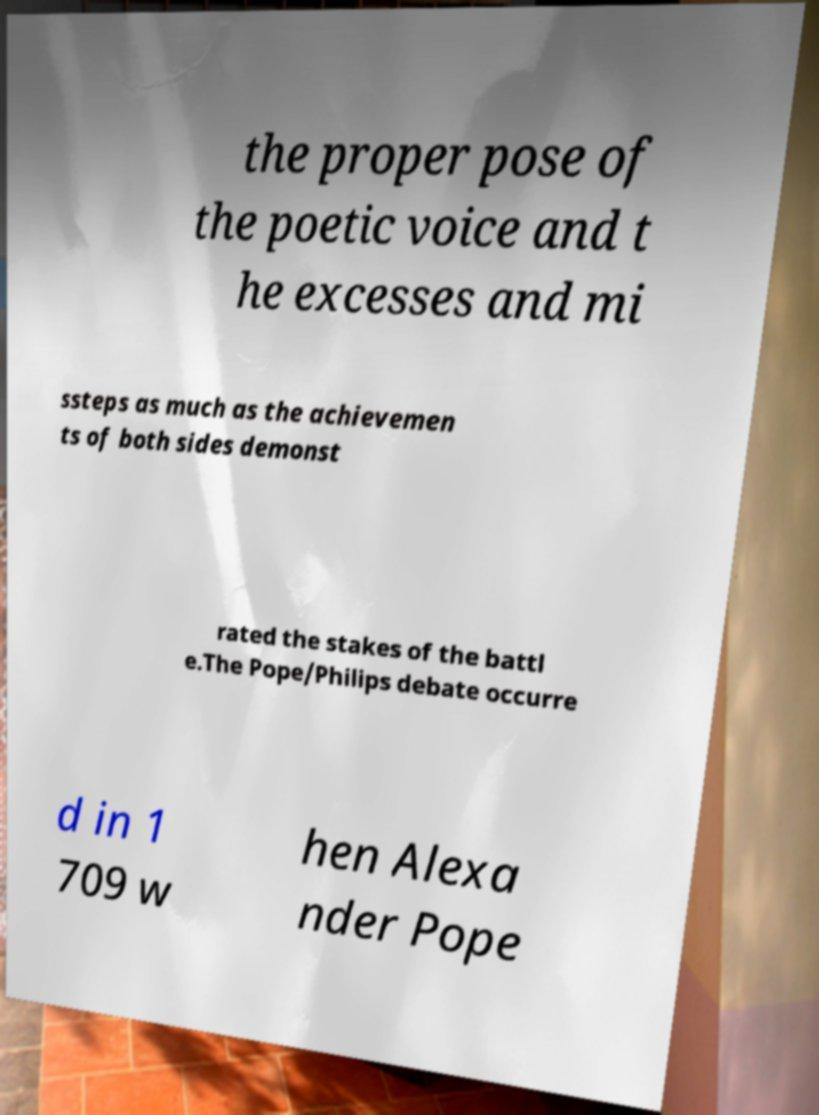Can you read and provide the text displayed in the image?This photo seems to have some interesting text. Can you extract and type it out for me? the proper pose of the poetic voice and t he excesses and mi ssteps as much as the achievemen ts of both sides demonst rated the stakes of the battl e.The Pope/Philips debate occurre d in 1 709 w hen Alexa nder Pope 